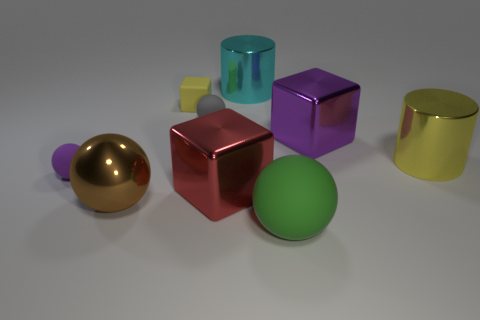Add 1 purple matte cubes. How many objects exist? 10 Subtract all cubes. How many objects are left? 6 Add 8 big metal cubes. How many big metal cubes are left? 10 Add 6 gray cylinders. How many gray cylinders exist? 6 Subtract 0 blue balls. How many objects are left? 9 Subtract all red matte cubes. Subtract all big cyan cylinders. How many objects are left? 8 